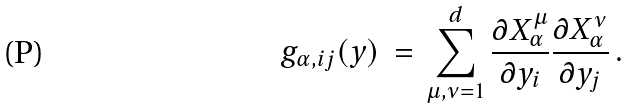Convert formula to latex. <formula><loc_0><loc_0><loc_500><loc_500>g _ { \alpha , i j } ( { y } ) \, = \, \sum _ { \mu , \nu = 1 } ^ { d } \frac { \partial X _ { \alpha } ^ { \mu } } { \partial y _ { i } } \frac { \partial X _ { \alpha } ^ { \nu } } { \partial y _ { j } } \, .</formula> 